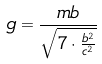<formula> <loc_0><loc_0><loc_500><loc_500>g = \frac { m b } { \sqrt { 7 \cdot \frac { b ^ { 2 } } { c ^ { 2 } } } }</formula> 